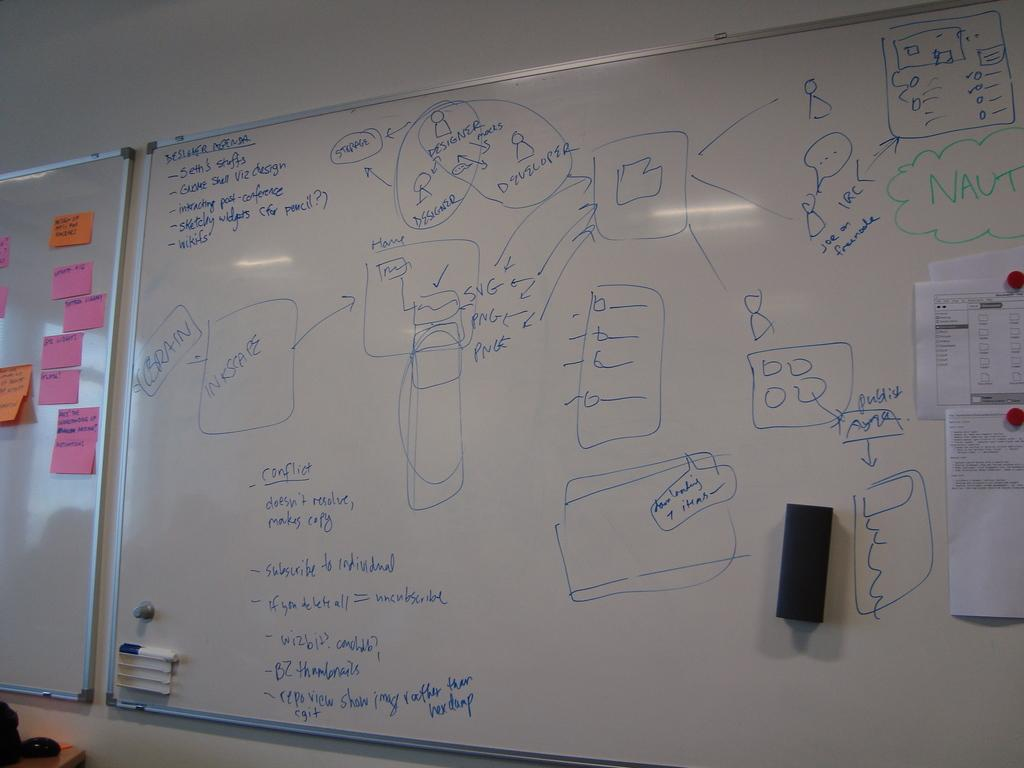<image>
Present a compact description of the photo's key features. A list of Designer Agenda is written on a white board. 